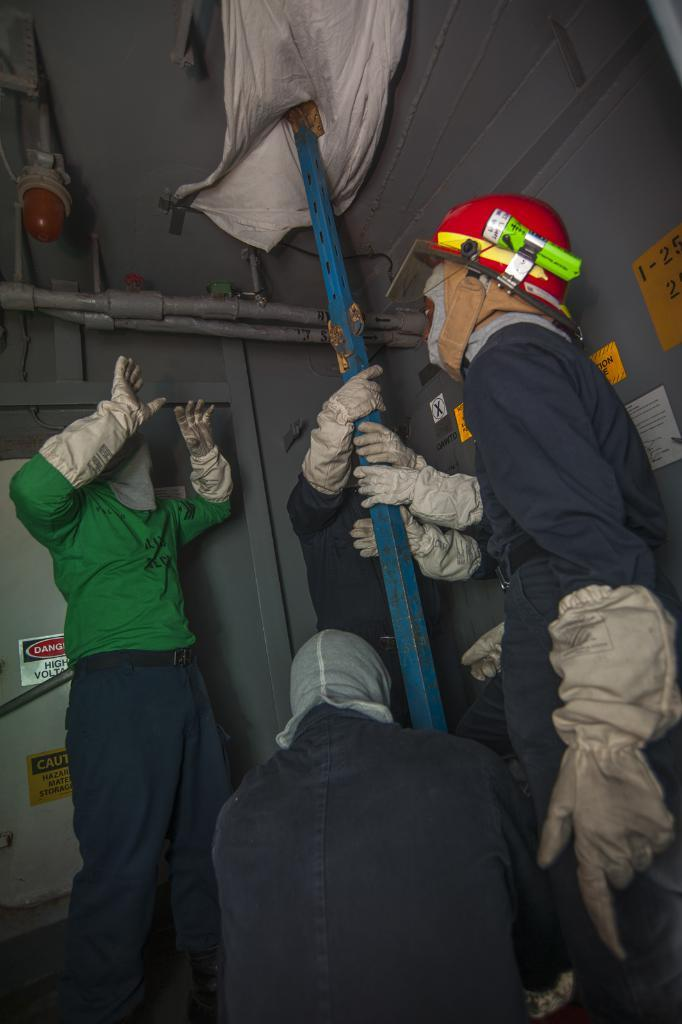What type of location is depicted in the image? The image shows an inside view of a house. Are there any people present in the image? Yes, there are people in the image. What object made of metal can be seen in the image? There is a metal rod in the image. What material is present in the image that is used for covering or decoration? There is cloth in the image. Can you describe the source of light in the image? There is a light in the image. What type of infrastructure is visible in the image? There are pipes in the image. What type of pollution can be seen in the image? There is no pollution visible in the image. Can you tell me how many clovers are present in the image? There are no clovers present in the image. 